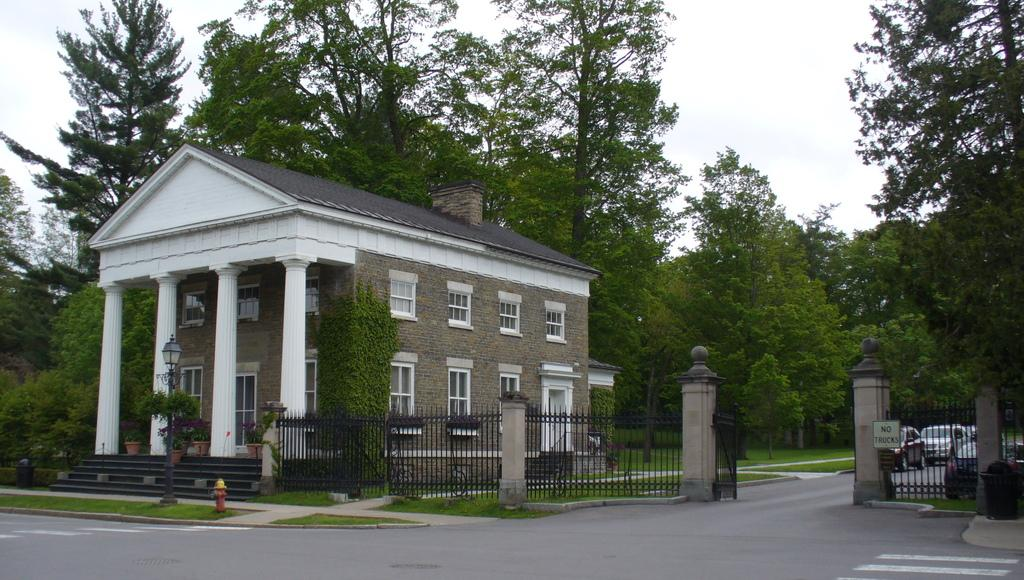What can be seen on the road in the image? There are vehicles on the road in the image. What structure is visible in the image? There is a building visible in the image. What type of natural elements can be seen in the image? There are trees present in the image. What type of pump is visible in the image? There is no pump present in the image. What appliance can be seen in the image? There is no appliance present in the image. 